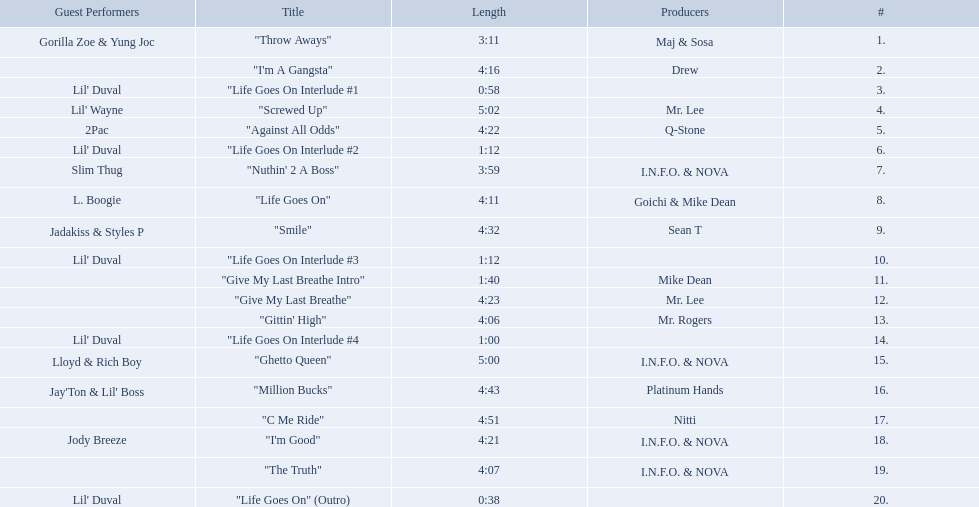What are the song lengths of all the songs on the album? 3:11, 4:16, 0:58, 5:02, 4:22, 1:12, 3:59, 4:11, 4:32, 1:12, 1:40, 4:23, 4:06, 1:00, 5:00, 4:43, 4:51, 4:21, 4:07, 0:38. Which is the longest of these? 5:02. 